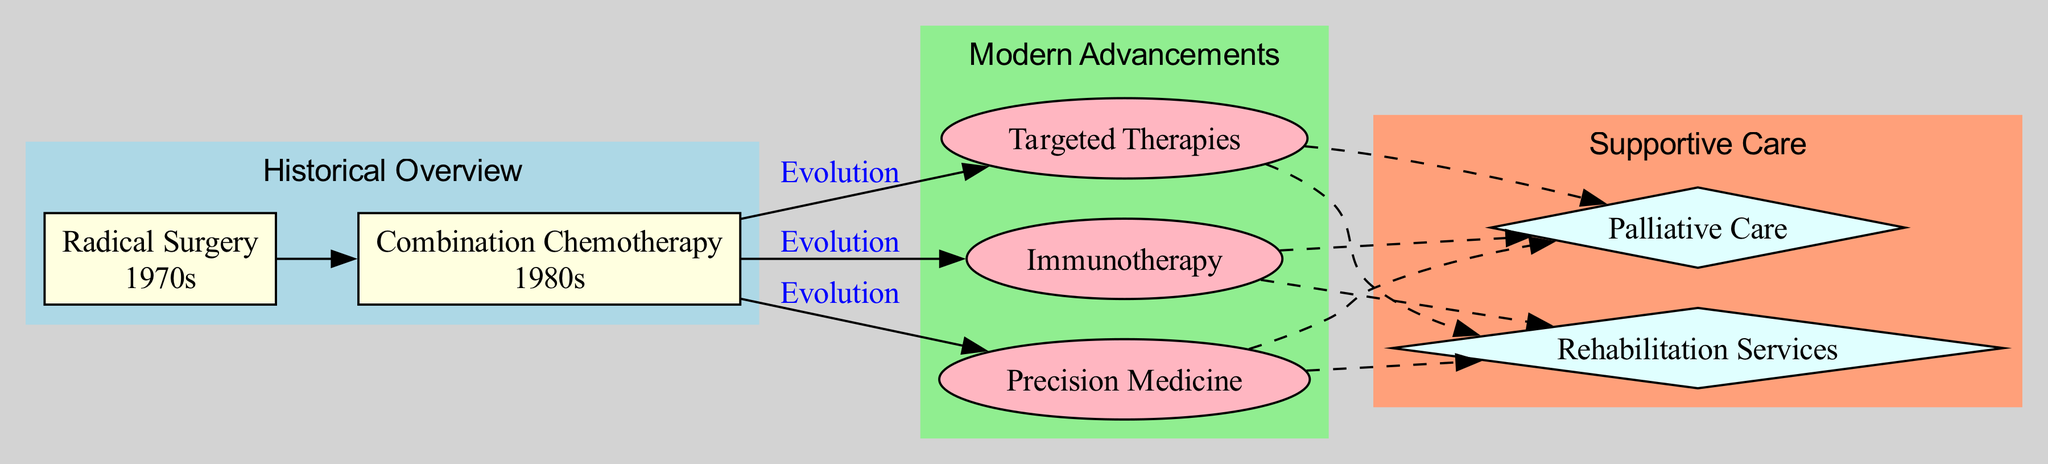What is the primary approach to cancer treatment in the 1970s? The diagram shows "Radical Surgery" as the primary approach to cancer treatment in the 1970s. This can be found in the section labeled "Historical Overview" specifically under "decade_1970s."
Answer: Radical Surgery Which chemotherapy regimen is mentioned from the 1980s? The example mentioned under the 1980s is "CHOP regimen for lymphoma," which indicates a specific approach from that decade in the "Historical Overview" section.
Answer: CHOP regimen How many modern advancements are listed in the diagram? By counting the nodes in the "Modern Advancements" section, there are three listed advancements: Targeted Therapies, Immunotherapy, and Precision Medicine.
Answer: 3 What do targeted therapies aim to do? The description provided in the "Modern Advancements" section specifies that targeted therapies aim to target specific genes or proteins in cancer cells. This illustrates their specific mechanism of action.
Answer: Target specific genes or proteins Which type of cancer treatment primarily focuses on quality of life? The diagram outlines "Palliative Care" as the type of cancer treatment that focuses on improving the quality of life for patients with serious illness. This is detailed in the "Supportive Care" section.
Answer: Palliative Care What is one example of immunotherapy mentioned in the diagram? Within the "Modern Advancements" section, "Checkpoint inhibitors like Pembrolizumab" is given as a specific example of immunotherapy. This highlights the various types of immunotherapies available.
Answer: Checkpoint inhibitors like Pembrolizumab What relationship is indicated between targeted therapies and supportive care? The diagram indicates a dashed edge connection from "Targeted Therapies" to "Palliative Care," suggesting an indirect relationship where targeted therapies can contribute to supportive care.
Answer: Indirect relationship In which decade did combination chemotherapy become the primary approach? According to the "Historical Overview," combination chemotherapy became the primary approach in the 1980s, specified under "decade_1980s."
Answer: 1980s What is a goal of precision medicine in cancer treatment? The diagram notes that precision medicine aims to customize treatment based on genetic profiles and biomarkers, emphasizing a personalized treatment approach for cancer patients.
Answer: Customize treatment based on genetic profiles 